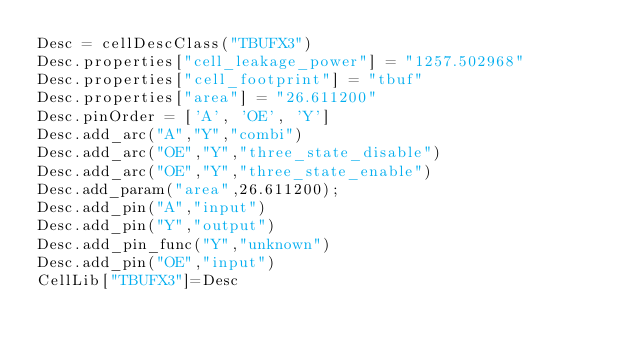<code> <loc_0><loc_0><loc_500><loc_500><_Python_>Desc = cellDescClass("TBUFX3")
Desc.properties["cell_leakage_power"] = "1257.502968"
Desc.properties["cell_footprint"] = "tbuf"
Desc.properties["area"] = "26.611200"
Desc.pinOrder = ['A', 'OE', 'Y']
Desc.add_arc("A","Y","combi")
Desc.add_arc("OE","Y","three_state_disable")
Desc.add_arc("OE","Y","three_state_enable")
Desc.add_param("area",26.611200);
Desc.add_pin("A","input")
Desc.add_pin("Y","output")
Desc.add_pin_func("Y","unknown")
Desc.add_pin("OE","input")
CellLib["TBUFX3"]=Desc
</code> 